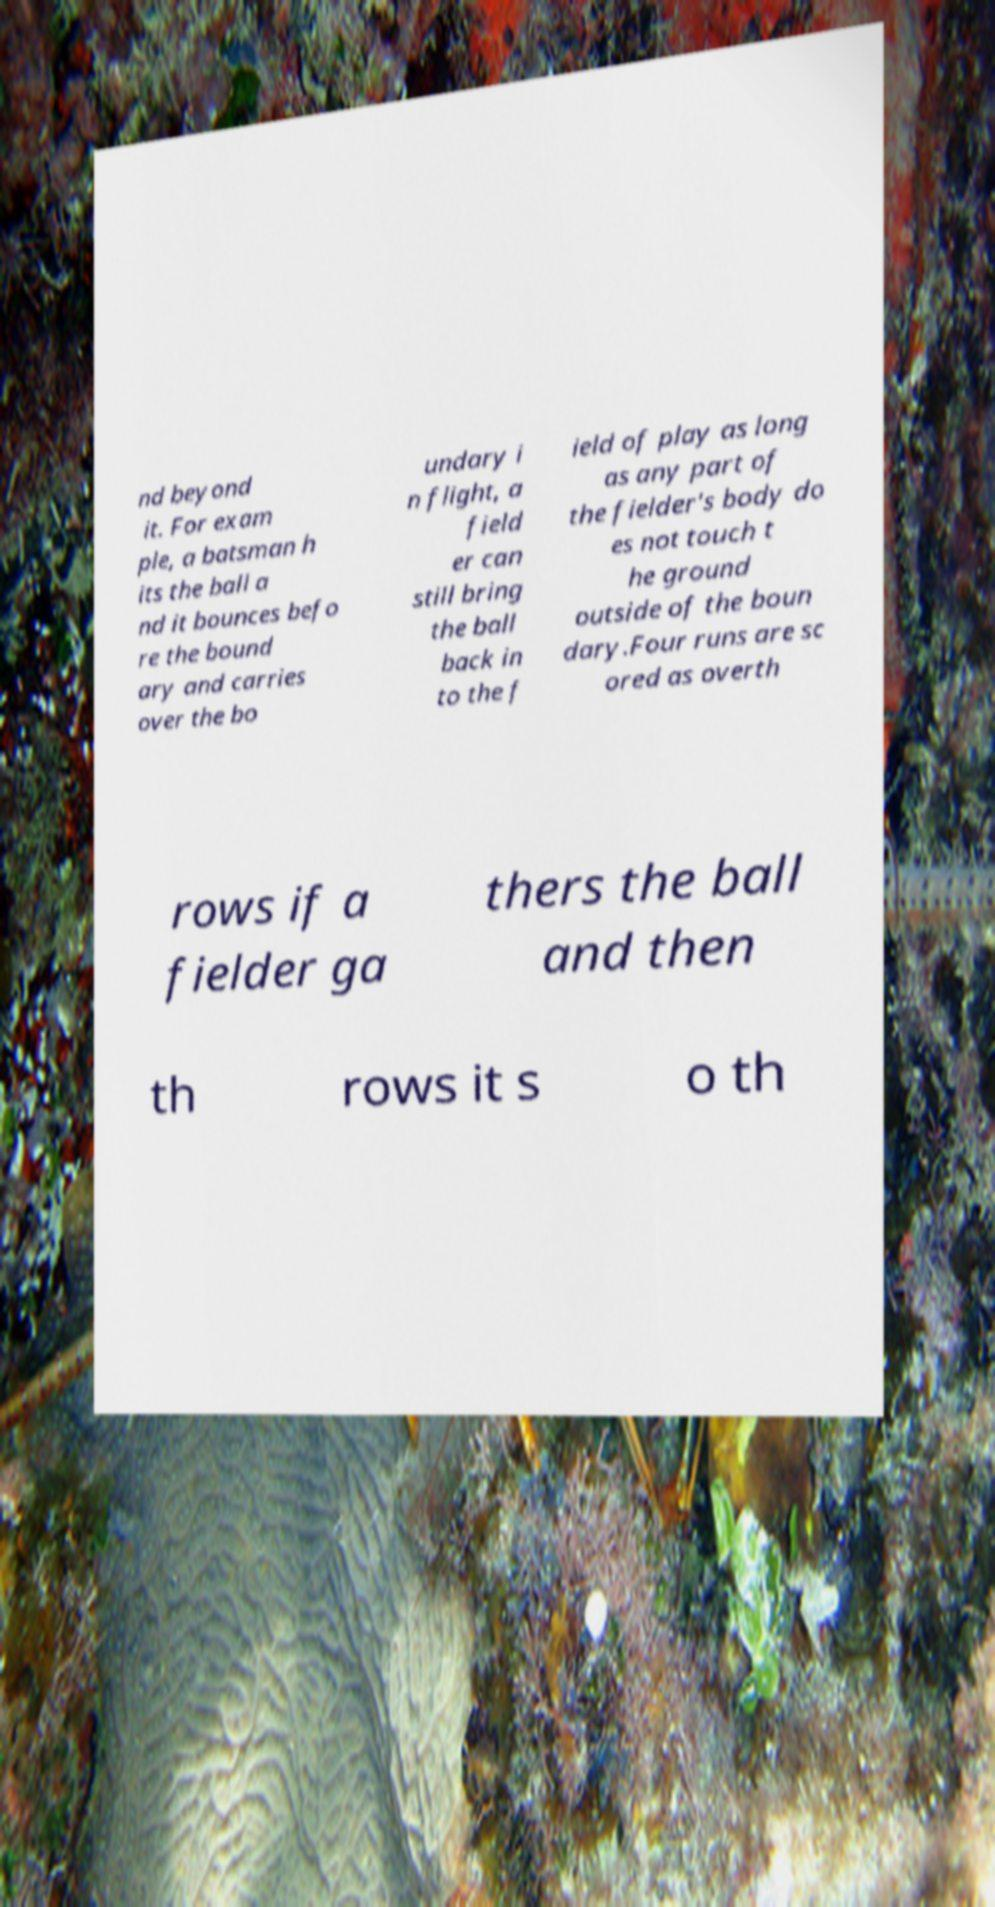Could you assist in decoding the text presented in this image and type it out clearly? nd beyond it. For exam ple, a batsman h its the ball a nd it bounces befo re the bound ary and carries over the bo undary i n flight, a field er can still bring the ball back in to the f ield of play as long as any part of the fielder's body do es not touch t he ground outside of the boun dary.Four runs are sc ored as overth rows if a fielder ga thers the ball and then th rows it s o th 